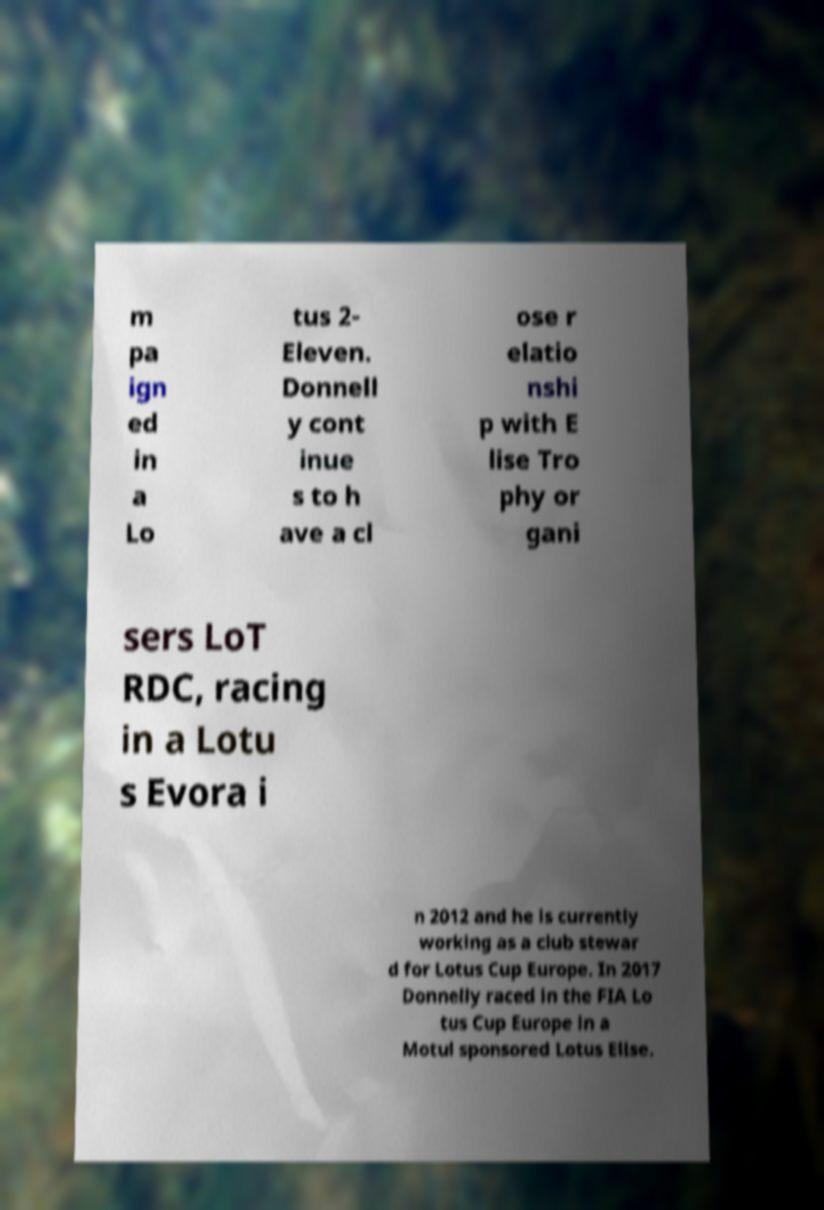What messages or text are displayed in this image? I need them in a readable, typed format. m pa ign ed in a Lo tus 2- Eleven. Donnell y cont inue s to h ave a cl ose r elatio nshi p with E lise Tro phy or gani sers LoT RDC, racing in a Lotu s Evora i n 2012 and he is currently working as a club stewar d for Lotus Cup Europe. In 2017 Donnelly raced in the FIA Lo tus Cup Europe in a Motul sponsored Lotus Elise. 